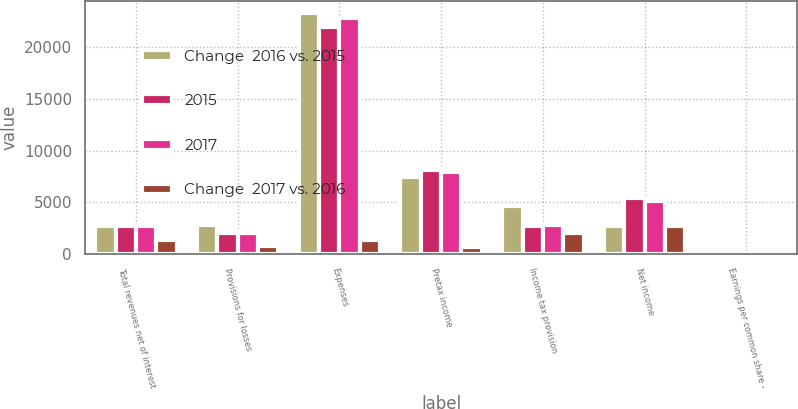Convert chart to OTSL. <chart><loc_0><loc_0><loc_500><loc_500><stacked_bar_chart><ecel><fcel>Total revenues net of interest<fcel>Provisions for losses<fcel>Expenses<fcel>Pretax income<fcel>Income tax provision<fcel>Net income<fcel>Earnings per common share -<nl><fcel>Change  2016 vs. 2015<fcel>2688<fcel>2759<fcel>23298<fcel>7414<fcel>4678<fcel>2736<fcel>2.97<nl><fcel>2015<fcel>2688<fcel>2026<fcel>21997<fcel>8096<fcel>2688<fcel>5408<fcel>5.65<nl><fcel>2017<fcel>2688<fcel>1988<fcel>22892<fcel>7938<fcel>2775<fcel>5163<fcel>5.05<nl><fcel>Change  2017 vs. 2016<fcel>1352<fcel>733<fcel>1301<fcel>682<fcel>1990<fcel>2672<fcel>2.68<nl></chart> 